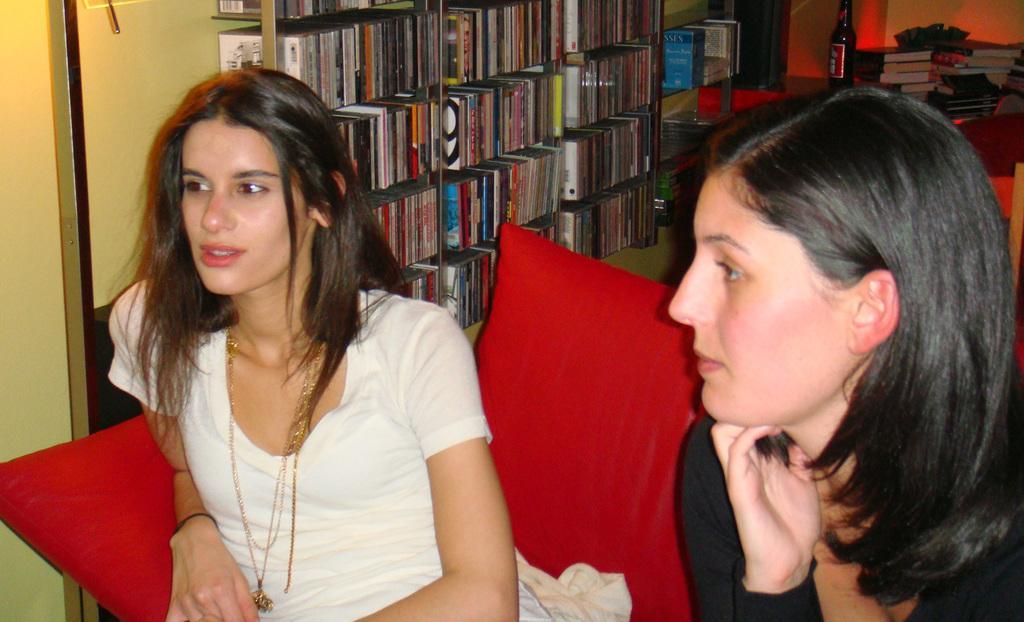In one or two sentences, can you explain what this image depicts? In this image there are two womens are sitting at bottom of this image , the left one is wearing white color t shirt and the right one is wearing a black color t shirt and there is a sofa at bottom of this image which is in red color. There is a rack at top of this image and there are some books kept in to these racks and there is a wall in the background and there are some books at top right corner of this image and there is one bottle at left side too these books and there is one table at top of this image. 